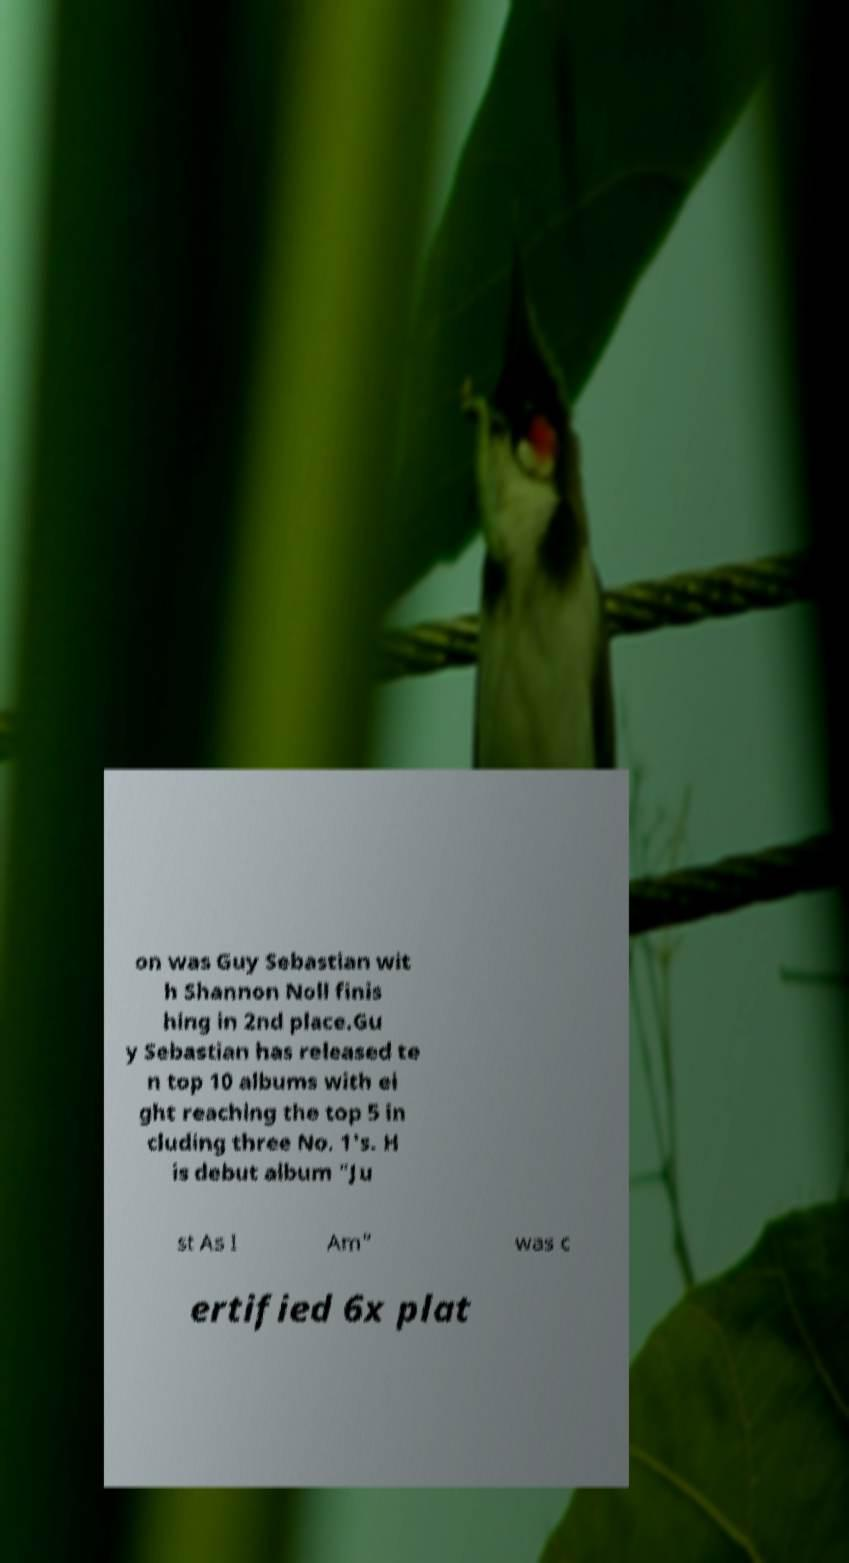Please read and relay the text visible in this image. What does it say? on was Guy Sebastian wit h Shannon Noll finis hing in 2nd place.Gu y Sebastian has released te n top 10 albums with ei ght reaching the top 5 in cluding three No. 1's. H is debut album "Ju st As I Am" was c ertified 6x plat 